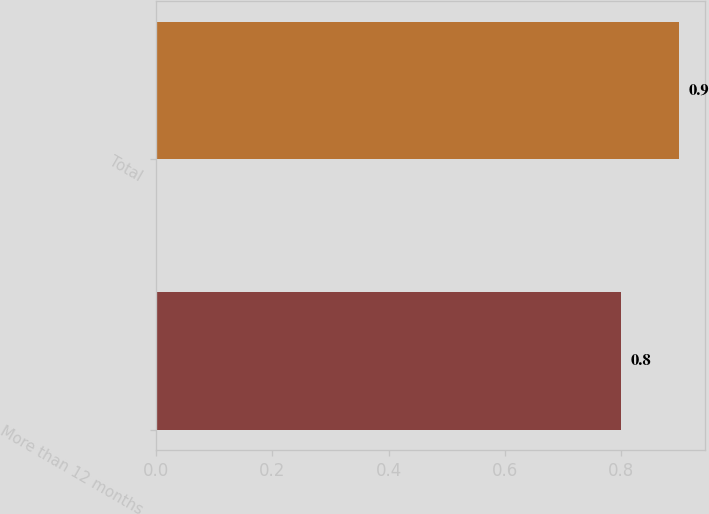Convert chart. <chart><loc_0><loc_0><loc_500><loc_500><bar_chart><fcel>More than 12 months<fcel>Total<nl><fcel>0.8<fcel>0.9<nl></chart> 